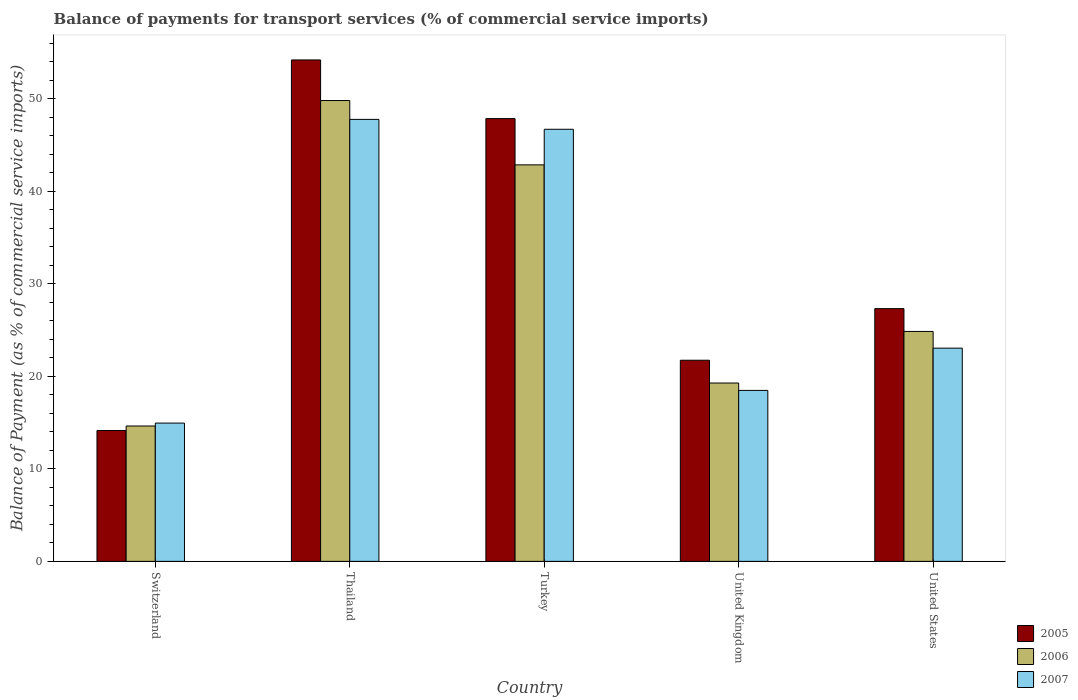How many different coloured bars are there?
Provide a short and direct response. 3. How many groups of bars are there?
Your answer should be very brief. 5. Are the number of bars per tick equal to the number of legend labels?
Offer a very short reply. Yes. Are the number of bars on each tick of the X-axis equal?
Your response must be concise. Yes. In how many cases, is the number of bars for a given country not equal to the number of legend labels?
Make the answer very short. 0. What is the balance of payments for transport services in 2007 in Turkey?
Your answer should be compact. 46.69. Across all countries, what is the maximum balance of payments for transport services in 2006?
Give a very brief answer. 49.79. Across all countries, what is the minimum balance of payments for transport services in 2005?
Your answer should be very brief. 14.14. In which country was the balance of payments for transport services in 2007 maximum?
Provide a succinct answer. Thailand. In which country was the balance of payments for transport services in 2005 minimum?
Offer a terse response. Switzerland. What is the total balance of payments for transport services in 2006 in the graph?
Your response must be concise. 151.38. What is the difference between the balance of payments for transport services in 2006 in Turkey and that in United Kingdom?
Offer a terse response. 23.57. What is the difference between the balance of payments for transport services in 2006 in Thailand and the balance of payments for transport services in 2005 in Switzerland?
Offer a terse response. 35.66. What is the average balance of payments for transport services in 2007 per country?
Your answer should be compact. 30.18. What is the difference between the balance of payments for transport services of/in 2005 and balance of payments for transport services of/in 2007 in United States?
Provide a succinct answer. 4.27. What is the ratio of the balance of payments for transport services in 2006 in Switzerland to that in Thailand?
Your response must be concise. 0.29. Is the balance of payments for transport services in 2006 in Thailand less than that in United Kingdom?
Your answer should be very brief. No. Is the difference between the balance of payments for transport services in 2005 in Thailand and Turkey greater than the difference between the balance of payments for transport services in 2007 in Thailand and Turkey?
Offer a very short reply. Yes. What is the difference between the highest and the second highest balance of payments for transport services in 2005?
Offer a very short reply. -26.87. What is the difference between the highest and the lowest balance of payments for transport services in 2005?
Provide a succinct answer. 40.04. Is the sum of the balance of payments for transport services in 2007 in Turkey and United States greater than the maximum balance of payments for transport services in 2005 across all countries?
Provide a short and direct response. Yes. Is it the case that in every country, the sum of the balance of payments for transport services in 2005 and balance of payments for transport services in 2007 is greater than the balance of payments for transport services in 2006?
Offer a very short reply. Yes. How many bars are there?
Keep it short and to the point. 15. How many countries are there in the graph?
Your answer should be very brief. 5. Does the graph contain any zero values?
Your answer should be very brief. No. What is the title of the graph?
Your response must be concise. Balance of payments for transport services (% of commercial service imports). What is the label or title of the X-axis?
Offer a terse response. Country. What is the label or title of the Y-axis?
Ensure brevity in your answer.  Balance of Payment (as % of commercial service imports). What is the Balance of Payment (as % of commercial service imports) in 2005 in Switzerland?
Your response must be concise. 14.14. What is the Balance of Payment (as % of commercial service imports) in 2006 in Switzerland?
Provide a succinct answer. 14.63. What is the Balance of Payment (as % of commercial service imports) of 2007 in Switzerland?
Your answer should be very brief. 14.94. What is the Balance of Payment (as % of commercial service imports) of 2005 in Thailand?
Provide a short and direct response. 54.18. What is the Balance of Payment (as % of commercial service imports) of 2006 in Thailand?
Offer a very short reply. 49.79. What is the Balance of Payment (as % of commercial service imports) of 2007 in Thailand?
Make the answer very short. 47.76. What is the Balance of Payment (as % of commercial service imports) in 2005 in Turkey?
Ensure brevity in your answer.  47.84. What is the Balance of Payment (as % of commercial service imports) in 2006 in Turkey?
Provide a succinct answer. 42.84. What is the Balance of Payment (as % of commercial service imports) of 2007 in Turkey?
Provide a short and direct response. 46.69. What is the Balance of Payment (as % of commercial service imports) in 2005 in United Kingdom?
Your response must be concise. 21.73. What is the Balance of Payment (as % of commercial service imports) of 2006 in United Kingdom?
Make the answer very short. 19.27. What is the Balance of Payment (as % of commercial service imports) of 2007 in United Kingdom?
Your answer should be compact. 18.47. What is the Balance of Payment (as % of commercial service imports) of 2005 in United States?
Make the answer very short. 27.31. What is the Balance of Payment (as % of commercial service imports) in 2006 in United States?
Offer a very short reply. 24.84. What is the Balance of Payment (as % of commercial service imports) of 2007 in United States?
Offer a terse response. 23.04. Across all countries, what is the maximum Balance of Payment (as % of commercial service imports) of 2005?
Offer a very short reply. 54.18. Across all countries, what is the maximum Balance of Payment (as % of commercial service imports) in 2006?
Offer a terse response. 49.79. Across all countries, what is the maximum Balance of Payment (as % of commercial service imports) of 2007?
Your response must be concise. 47.76. Across all countries, what is the minimum Balance of Payment (as % of commercial service imports) in 2005?
Your response must be concise. 14.14. Across all countries, what is the minimum Balance of Payment (as % of commercial service imports) of 2006?
Offer a terse response. 14.63. Across all countries, what is the minimum Balance of Payment (as % of commercial service imports) of 2007?
Provide a succinct answer. 14.94. What is the total Balance of Payment (as % of commercial service imports) in 2005 in the graph?
Offer a terse response. 165.2. What is the total Balance of Payment (as % of commercial service imports) of 2006 in the graph?
Keep it short and to the point. 151.38. What is the total Balance of Payment (as % of commercial service imports) in 2007 in the graph?
Offer a terse response. 150.9. What is the difference between the Balance of Payment (as % of commercial service imports) of 2005 in Switzerland and that in Thailand?
Your answer should be very brief. -40.04. What is the difference between the Balance of Payment (as % of commercial service imports) of 2006 in Switzerland and that in Thailand?
Make the answer very short. -35.17. What is the difference between the Balance of Payment (as % of commercial service imports) in 2007 in Switzerland and that in Thailand?
Your response must be concise. -32.82. What is the difference between the Balance of Payment (as % of commercial service imports) of 2005 in Switzerland and that in Turkey?
Ensure brevity in your answer.  -33.7. What is the difference between the Balance of Payment (as % of commercial service imports) in 2006 in Switzerland and that in Turkey?
Make the answer very short. -28.21. What is the difference between the Balance of Payment (as % of commercial service imports) in 2007 in Switzerland and that in Turkey?
Ensure brevity in your answer.  -31.75. What is the difference between the Balance of Payment (as % of commercial service imports) in 2005 in Switzerland and that in United Kingdom?
Your answer should be compact. -7.59. What is the difference between the Balance of Payment (as % of commercial service imports) in 2006 in Switzerland and that in United Kingdom?
Your answer should be compact. -4.64. What is the difference between the Balance of Payment (as % of commercial service imports) in 2007 in Switzerland and that in United Kingdom?
Your answer should be very brief. -3.53. What is the difference between the Balance of Payment (as % of commercial service imports) in 2005 in Switzerland and that in United States?
Your answer should be very brief. -13.17. What is the difference between the Balance of Payment (as % of commercial service imports) of 2006 in Switzerland and that in United States?
Keep it short and to the point. -10.21. What is the difference between the Balance of Payment (as % of commercial service imports) in 2007 in Switzerland and that in United States?
Your response must be concise. -8.1. What is the difference between the Balance of Payment (as % of commercial service imports) of 2005 in Thailand and that in Turkey?
Ensure brevity in your answer.  6.34. What is the difference between the Balance of Payment (as % of commercial service imports) of 2006 in Thailand and that in Turkey?
Provide a succinct answer. 6.95. What is the difference between the Balance of Payment (as % of commercial service imports) in 2007 in Thailand and that in Turkey?
Ensure brevity in your answer.  1.07. What is the difference between the Balance of Payment (as % of commercial service imports) in 2005 in Thailand and that in United Kingdom?
Give a very brief answer. 32.45. What is the difference between the Balance of Payment (as % of commercial service imports) in 2006 in Thailand and that in United Kingdom?
Make the answer very short. 30.52. What is the difference between the Balance of Payment (as % of commercial service imports) in 2007 in Thailand and that in United Kingdom?
Provide a succinct answer. 29.29. What is the difference between the Balance of Payment (as % of commercial service imports) of 2005 in Thailand and that in United States?
Give a very brief answer. 26.87. What is the difference between the Balance of Payment (as % of commercial service imports) of 2006 in Thailand and that in United States?
Keep it short and to the point. 24.95. What is the difference between the Balance of Payment (as % of commercial service imports) in 2007 in Thailand and that in United States?
Ensure brevity in your answer.  24.72. What is the difference between the Balance of Payment (as % of commercial service imports) of 2005 in Turkey and that in United Kingdom?
Offer a terse response. 26.11. What is the difference between the Balance of Payment (as % of commercial service imports) in 2006 in Turkey and that in United Kingdom?
Provide a succinct answer. 23.57. What is the difference between the Balance of Payment (as % of commercial service imports) of 2007 in Turkey and that in United Kingdom?
Provide a succinct answer. 28.22. What is the difference between the Balance of Payment (as % of commercial service imports) in 2005 in Turkey and that in United States?
Your answer should be compact. 20.53. What is the difference between the Balance of Payment (as % of commercial service imports) of 2006 in Turkey and that in United States?
Keep it short and to the point. 18. What is the difference between the Balance of Payment (as % of commercial service imports) in 2007 in Turkey and that in United States?
Provide a short and direct response. 23.65. What is the difference between the Balance of Payment (as % of commercial service imports) in 2005 in United Kingdom and that in United States?
Offer a terse response. -5.58. What is the difference between the Balance of Payment (as % of commercial service imports) in 2006 in United Kingdom and that in United States?
Your answer should be very brief. -5.57. What is the difference between the Balance of Payment (as % of commercial service imports) in 2007 in United Kingdom and that in United States?
Offer a terse response. -4.57. What is the difference between the Balance of Payment (as % of commercial service imports) in 2005 in Switzerland and the Balance of Payment (as % of commercial service imports) in 2006 in Thailand?
Provide a short and direct response. -35.66. What is the difference between the Balance of Payment (as % of commercial service imports) in 2005 in Switzerland and the Balance of Payment (as % of commercial service imports) in 2007 in Thailand?
Provide a short and direct response. -33.62. What is the difference between the Balance of Payment (as % of commercial service imports) in 2006 in Switzerland and the Balance of Payment (as % of commercial service imports) in 2007 in Thailand?
Give a very brief answer. -33.13. What is the difference between the Balance of Payment (as % of commercial service imports) of 2005 in Switzerland and the Balance of Payment (as % of commercial service imports) of 2006 in Turkey?
Ensure brevity in your answer.  -28.7. What is the difference between the Balance of Payment (as % of commercial service imports) of 2005 in Switzerland and the Balance of Payment (as % of commercial service imports) of 2007 in Turkey?
Provide a short and direct response. -32.55. What is the difference between the Balance of Payment (as % of commercial service imports) in 2006 in Switzerland and the Balance of Payment (as % of commercial service imports) in 2007 in Turkey?
Provide a short and direct response. -32.06. What is the difference between the Balance of Payment (as % of commercial service imports) in 2005 in Switzerland and the Balance of Payment (as % of commercial service imports) in 2006 in United Kingdom?
Provide a short and direct response. -5.13. What is the difference between the Balance of Payment (as % of commercial service imports) of 2005 in Switzerland and the Balance of Payment (as % of commercial service imports) of 2007 in United Kingdom?
Offer a very short reply. -4.33. What is the difference between the Balance of Payment (as % of commercial service imports) of 2006 in Switzerland and the Balance of Payment (as % of commercial service imports) of 2007 in United Kingdom?
Make the answer very short. -3.84. What is the difference between the Balance of Payment (as % of commercial service imports) in 2005 in Switzerland and the Balance of Payment (as % of commercial service imports) in 2006 in United States?
Your response must be concise. -10.7. What is the difference between the Balance of Payment (as % of commercial service imports) in 2005 in Switzerland and the Balance of Payment (as % of commercial service imports) in 2007 in United States?
Your response must be concise. -8.9. What is the difference between the Balance of Payment (as % of commercial service imports) in 2006 in Switzerland and the Balance of Payment (as % of commercial service imports) in 2007 in United States?
Your answer should be very brief. -8.41. What is the difference between the Balance of Payment (as % of commercial service imports) of 2005 in Thailand and the Balance of Payment (as % of commercial service imports) of 2006 in Turkey?
Your response must be concise. 11.34. What is the difference between the Balance of Payment (as % of commercial service imports) of 2005 in Thailand and the Balance of Payment (as % of commercial service imports) of 2007 in Turkey?
Provide a succinct answer. 7.49. What is the difference between the Balance of Payment (as % of commercial service imports) of 2006 in Thailand and the Balance of Payment (as % of commercial service imports) of 2007 in Turkey?
Your answer should be compact. 3.11. What is the difference between the Balance of Payment (as % of commercial service imports) of 2005 in Thailand and the Balance of Payment (as % of commercial service imports) of 2006 in United Kingdom?
Provide a succinct answer. 34.91. What is the difference between the Balance of Payment (as % of commercial service imports) in 2005 in Thailand and the Balance of Payment (as % of commercial service imports) in 2007 in United Kingdom?
Make the answer very short. 35.71. What is the difference between the Balance of Payment (as % of commercial service imports) in 2006 in Thailand and the Balance of Payment (as % of commercial service imports) in 2007 in United Kingdom?
Offer a terse response. 31.32. What is the difference between the Balance of Payment (as % of commercial service imports) of 2005 in Thailand and the Balance of Payment (as % of commercial service imports) of 2006 in United States?
Make the answer very short. 29.34. What is the difference between the Balance of Payment (as % of commercial service imports) in 2005 in Thailand and the Balance of Payment (as % of commercial service imports) in 2007 in United States?
Your answer should be compact. 31.14. What is the difference between the Balance of Payment (as % of commercial service imports) of 2006 in Thailand and the Balance of Payment (as % of commercial service imports) of 2007 in United States?
Keep it short and to the point. 26.76. What is the difference between the Balance of Payment (as % of commercial service imports) of 2005 in Turkey and the Balance of Payment (as % of commercial service imports) of 2006 in United Kingdom?
Offer a very short reply. 28.57. What is the difference between the Balance of Payment (as % of commercial service imports) of 2005 in Turkey and the Balance of Payment (as % of commercial service imports) of 2007 in United Kingdom?
Offer a terse response. 29.37. What is the difference between the Balance of Payment (as % of commercial service imports) of 2006 in Turkey and the Balance of Payment (as % of commercial service imports) of 2007 in United Kingdom?
Your response must be concise. 24.37. What is the difference between the Balance of Payment (as % of commercial service imports) in 2005 in Turkey and the Balance of Payment (as % of commercial service imports) in 2006 in United States?
Your response must be concise. 23. What is the difference between the Balance of Payment (as % of commercial service imports) of 2005 in Turkey and the Balance of Payment (as % of commercial service imports) of 2007 in United States?
Your response must be concise. 24.8. What is the difference between the Balance of Payment (as % of commercial service imports) of 2006 in Turkey and the Balance of Payment (as % of commercial service imports) of 2007 in United States?
Give a very brief answer. 19.8. What is the difference between the Balance of Payment (as % of commercial service imports) in 2005 in United Kingdom and the Balance of Payment (as % of commercial service imports) in 2006 in United States?
Offer a terse response. -3.11. What is the difference between the Balance of Payment (as % of commercial service imports) in 2005 in United Kingdom and the Balance of Payment (as % of commercial service imports) in 2007 in United States?
Your answer should be compact. -1.31. What is the difference between the Balance of Payment (as % of commercial service imports) of 2006 in United Kingdom and the Balance of Payment (as % of commercial service imports) of 2007 in United States?
Offer a very short reply. -3.77. What is the average Balance of Payment (as % of commercial service imports) in 2005 per country?
Give a very brief answer. 33.04. What is the average Balance of Payment (as % of commercial service imports) of 2006 per country?
Offer a very short reply. 30.28. What is the average Balance of Payment (as % of commercial service imports) in 2007 per country?
Provide a short and direct response. 30.18. What is the difference between the Balance of Payment (as % of commercial service imports) of 2005 and Balance of Payment (as % of commercial service imports) of 2006 in Switzerland?
Your response must be concise. -0.49. What is the difference between the Balance of Payment (as % of commercial service imports) in 2005 and Balance of Payment (as % of commercial service imports) in 2007 in Switzerland?
Your answer should be compact. -0.8. What is the difference between the Balance of Payment (as % of commercial service imports) of 2006 and Balance of Payment (as % of commercial service imports) of 2007 in Switzerland?
Your response must be concise. -0.31. What is the difference between the Balance of Payment (as % of commercial service imports) of 2005 and Balance of Payment (as % of commercial service imports) of 2006 in Thailand?
Ensure brevity in your answer.  4.39. What is the difference between the Balance of Payment (as % of commercial service imports) in 2005 and Balance of Payment (as % of commercial service imports) in 2007 in Thailand?
Ensure brevity in your answer.  6.42. What is the difference between the Balance of Payment (as % of commercial service imports) in 2006 and Balance of Payment (as % of commercial service imports) in 2007 in Thailand?
Offer a terse response. 2.04. What is the difference between the Balance of Payment (as % of commercial service imports) of 2005 and Balance of Payment (as % of commercial service imports) of 2006 in Turkey?
Make the answer very short. 5. What is the difference between the Balance of Payment (as % of commercial service imports) in 2005 and Balance of Payment (as % of commercial service imports) in 2007 in Turkey?
Your answer should be compact. 1.15. What is the difference between the Balance of Payment (as % of commercial service imports) in 2006 and Balance of Payment (as % of commercial service imports) in 2007 in Turkey?
Keep it short and to the point. -3.85. What is the difference between the Balance of Payment (as % of commercial service imports) in 2005 and Balance of Payment (as % of commercial service imports) in 2006 in United Kingdom?
Ensure brevity in your answer.  2.46. What is the difference between the Balance of Payment (as % of commercial service imports) of 2005 and Balance of Payment (as % of commercial service imports) of 2007 in United Kingdom?
Your answer should be compact. 3.26. What is the difference between the Balance of Payment (as % of commercial service imports) of 2006 and Balance of Payment (as % of commercial service imports) of 2007 in United Kingdom?
Your answer should be very brief. 0.8. What is the difference between the Balance of Payment (as % of commercial service imports) in 2005 and Balance of Payment (as % of commercial service imports) in 2006 in United States?
Make the answer very short. 2.47. What is the difference between the Balance of Payment (as % of commercial service imports) in 2005 and Balance of Payment (as % of commercial service imports) in 2007 in United States?
Ensure brevity in your answer.  4.27. What is the difference between the Balance of Payment (as % of commercial service imports) of 2006 and Balance of Payment (as % of commercial service imports) of 2007 in United States?
Make the answer very short. 1.8. What is the ratio of the Balance of Payment (as % of commercial service imports) in 2005 in Switzerland to that in Thailand?
Your response must be concise. 0.26. What is the ratio of the Balance of Payment (as % of commercial service imports) in 2006 in Switzerland to that in Thailand?
Ensure brevity in your answer.  0.29. What is the ratio of the Balance of Payment (as % of commercial service imports) in 2007 in Switzerland to that in Thailand?
Your answer should be very brief. 0.31. What is the ratio of the Balance of Payment (as % of commercial service imports) of 2005 in Switzerland to that in Turkey?
Make the answer very short. 0.3. What is the ratio of the Balance of Payment (as % of commercial service imports) of 2006 in Switzerland to that in Turkey?
Offer a terse response. 0.34. What is the ratio of the Balance of Payment (as % of commercial service imports) of 2007 in Switzerland to that in Turkey?
Offer a terse response. 0.32. What is the ratio of the Balance of Payment (as % of commercial service imports) in 2005 in Switzerland to that in United Kingdom?
Provide a short and direct response. 0.65. What is the ratio of the Balance of Payment (as % of commercial service imports) in 2006 in Switzerland to that in United Kingdom?
Ensure brevity in your answer.  0.76. What is the ratio of the Balance of Payment (as % of commercial service imports) in 2007 in Switzerland to that in United Kingdom?
Give a very brief answer. 0.81. What is the ratio of the Balance of Payment (as % of commercial service imports) in 2005 in Switzerland to that in United States?
Offer a very short reply. 0.52. What is the ratio of the Balance of Payment (as % of commercial service imports) in 2006 in Switzerland to that in United States?
Offer a terse response. 0.59. What is the ratio of the Balance of Payment (as % of commercial service imports) in 2007 in Switzerland to that in United States?
Keep it short and to the point. 0.65. What is the ratio of the Balance of Payment (as % of commercial service imports) of 2005 in Thailand to that in Turkey?
Your answer should be very brief. 1.13. What is the ratio of the Balance of Payment (as % of commercial service imports) of 2006 in Thailand to that in Turkey?
Provide a succinct answer. 1.16. What is the ratio of the Balance of Payment (as % of commercial service imports) of 2007 in Thailand to that in Turkey?
Keep it short and to the point. 1.02. What is the ratio of the Balance of Payment (as % of commercial service imports) of 2005 in Thailand to that in United Kingdom?
Give a very brief answer. 2.49. What is the ratio of the Balance of Payment (as % of commercial service imports) in 2006 in Thailand to that in United Kingdom?
Ensure brevity in your answer.  2.58. What is the ratio of the Balance of Payment (as % of commercial service imports) of 2007 in Thailand to that in United Kingdom?
Provide a short and direct response. 2.59. What is the ratio of the Balance of Payment (as % of commercial service imports) in 2005 in Thailand to that in United States?
Your answer should be compact. 1.98. What is the ratio of the Balance of Payment (as % of commercial service imports) in 2006 in Thailand to that in United States?
Provide a succinct answer. 2. What is the ratio of the Balance of Payment (as % of commercial service imports) of 2007 in Thailand to that in United States?
Keep it short and to the point. 2.07. What is the ratio of the Balance of Payment (as % of commercial service imports) in 2005 in Turkey to that in United Kingdom?
Give a very brief answer. 2.2. What is the ratio of the Balance of Payment (as % of commercial service imports) of 2006 in Turkey to that in United Kingdom?
Your answer should be very brief. 2.22. What is the ratio of the Balance of Payment (as % of commercial service imports) in 2007 in Turkey to that in United Kingdom?
Make the answer very short. 2.53. What is the ratio of the Balance of Payment (as % of commercial service imports) of 2005 in Turkey to that in United States?
Make the answer very short. 1.75. What is the ratio of the Balance of Payment (as % of commercial service imports) in 2006 in Turkey to that in United States?
Your response must be concise. 1.72. What is the ratio of the Balance of Payment (as % of commercial service imports) of 2007 in Turkey to that in United States?
Make the answer very short. 2.03. What is the ratio of the Balance of Payment (as % of commercial service imports) of 2005 in United Kingdom to that in United States?
Your answer should be very brief. 0.8. What is the ratio of the Balance of Payment (as % of commercial service imports) in 2006 in United Kingdom to that in United States?
Keep it short and to the point. 0.78. What is the ratio of the Balance of Payment (as % of commercial service imports) in 2007 in United Kingdom to that in United States?
Give a very brief answer. 0.8. What is the difference between the highest and the second highest Balance of Payment (as % of commercial service imports) of 2005?
Ensure brevity in your answer.  6.34. What is the difference between the highest and the second highest Balance of Payment (as % of commercial service imports) of 2006?
Give a very brief answer. 6.95. What is the difference between the highest and the second highest Balance of Payment (as % of commercial service imports) in 2007?
Keep it short and to the point. 1.07. What is the difference between the highest and the lowest Balance of Payment (as % of commercial service imports) in 2005?
Provide a succinct answer. 40.04. What is the difference between the highest and the lowest Balance of Payment (as % of commercial service imports) of 2006?
Offer a terse response. 35.17. What is the difference between the highest and the lowest Balance of Payment (as % of commercial service imports) of 2007?
Provide a succinct answer. 32.82. 